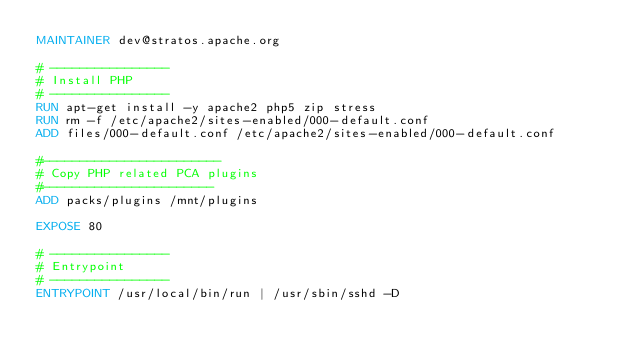<code> <loc_0><loc_0><loc_500><loc_500><_Dockerfile_>MAINTAINER dev@stratos.apache.org

# ----------------
# Install PHP
# ----------------
RUN apt-get install -y apache2 php5 zip stress
RUN rm -f /etc/apache2/sites-enabled/000-default.conf
ADD files/000-default.conf /etc/apache2/sites-enabled/000-default.conf

#------------------------
# Copy PHP related PCA plugins
#-----------------------
ADD packs/plugins /mnt/plugins

EXPOSE 80

# ----------------
# Entrypoint
# ----------------
ENTRYPOINT /usr/local/bin/run | /usr/sbin/sshd -D
</code> 